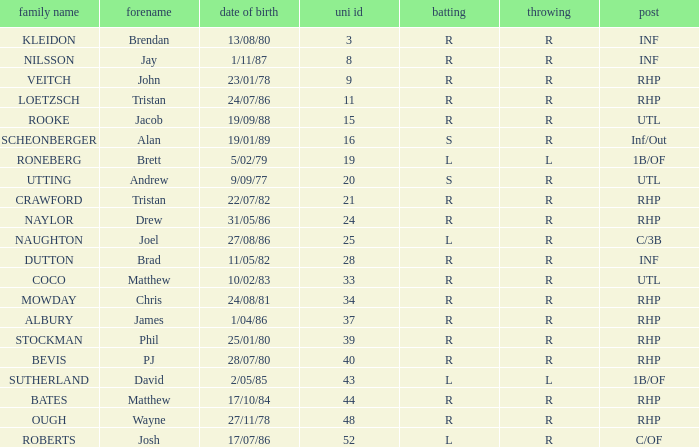Which Position has a Surname of naylor? RHP. 